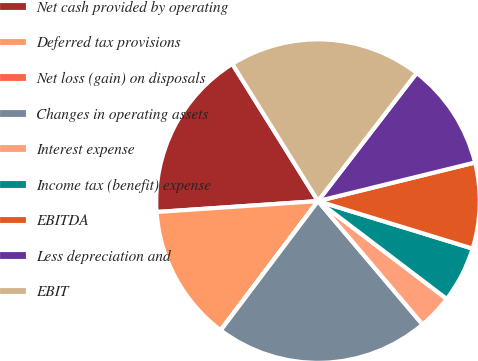<chart> <loc_0><loc_0><loc_500><loc_500><pie_chart><fcel>Net cash provided by operating<fcel>Deferred tax provisions<fcel>Net loss (gain) on disposals<fcel>Changes in operating assets<fcel>Interest expense<fcel>Income tax (benefit) expense<fcel>EBITDA<fcel>Less depreciation and<fcel>EBIT<nl><fcel>17.19%<fcel>13.65%<fcel>0.01%<fcel>21.46%<fcel>3.47%<fcel>5.6%<fcel>8.58%<fcel>10.72%<fcel>19.33%<nl></chart> 